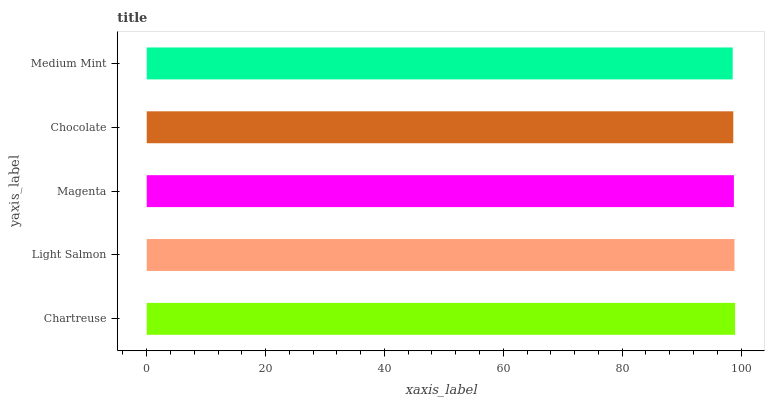Is Medium Mint the minimum?
Answer yes or no. Yes. Is Chartreuse the maximum?
Answer yes or no. Yes. Is Light Salmon the minimum?
Answer yes or no. No. Is Light Salmon the maximum?
Answer yes or no. No. Is Chartreuse greater than Light Salmon?
Answer yes or no. Yes. Is Light Salmon less than Chartreuse?
Answer yes or no. Yes. Is Light Salmon greater than Chartreuse?
Answer yes or no. No. Is Chartreuse less than Light Salmon?
Answer yes or no. No. Is Magenta the high median?
Answer yes or no. Yes. Is Magenta the low median?
Answer yes or no. Yes. Is Chartreuse the high median?
Answer yes or no. No. Is Chocolate the low median?
Answer yes or no. No. 